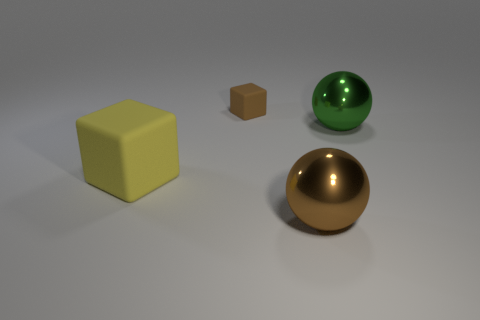Is the material of the large brown sphere the same as the cube in front of the large green object?
Keep it short and to the point. No. Are there fewer tiny brown blocks on the left side of the big rubber object than objects that are in front of the big green ball?
Your answer should be compact. Yes. How many other big brown spheres have the same material as the brown sphere?
Keep it short and to the point. 0. Is there a rubber cube on the right side of the thing to the right of the large sphere left of the large green metal ball?
Your answer should be compact. No. How many balls are either big yellow things or tiny things?
Provide a succinct answer. 0. Do the small thing and the large object to the left of the brown matte block have the same shape?
Ensure brevity in your answer.  Yes. Are there fewer yellow matte things that are on the right side of the green thing than tiny brown objects?
Provide a short and direct response. Yes. Are there any brown metal balls behind the brown matte object?
Provide a succinct answer. No. Is there a tiny blue object of the same shape as the green metal object?
Offer a very short reply. No. What shape is the yellow object that is the same size as the brown shiny ball?
Ensure brevity in your answer.  Cube. 